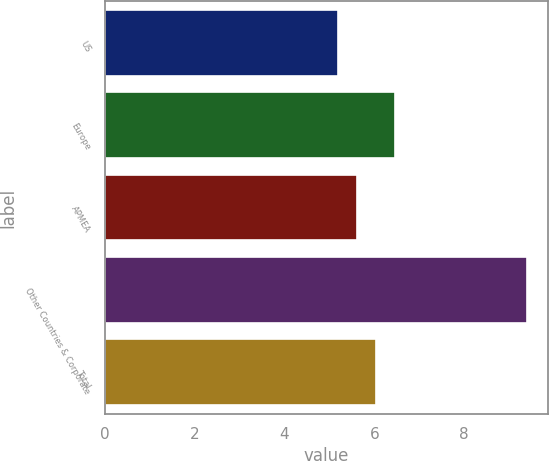Convert chart. <chart><loc_0><loc_0><loc_500><loc_500><bar_chart><fcel>US<fcel>Europe<fcel>APMEA<fcel>Other Countries & Corporate<fcel>Total<nl><fcel>5.2<fcel>6.46<fcel>5.62<fcel>9.4<fcel>6.04<nl></chart> 